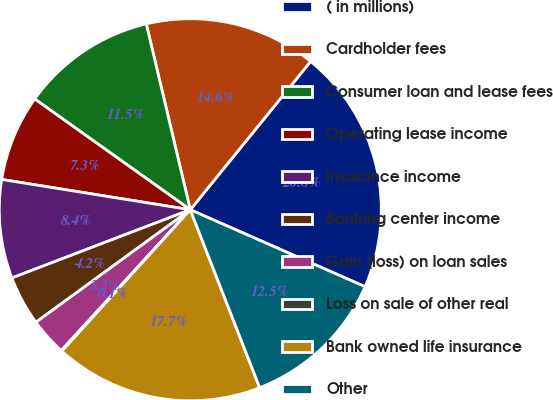<chart> <loc_0><loc_0><loc_500><loc_500><pie_chart><fcel>( in millions)<fcel>Cardholder fees<fcel>Consumer loan and lease fees<fcel>Operating lease income<fcel>Insurance income<fcel>Banking center income<fcel>Gain (loss) on loan sales<fcel>Loss on sale of other real<fcel>Bank owned life insurance<fcel>Other<nl><fcel>20.75%<fcel>14.55%<fcel>11.45%<fcel>7.31%<fcel>8.35%<fcel>4.21%<fcel>3.17%<fcel>0.07%<fcel>17.65%<fcel>12.48%<nl></chart> 